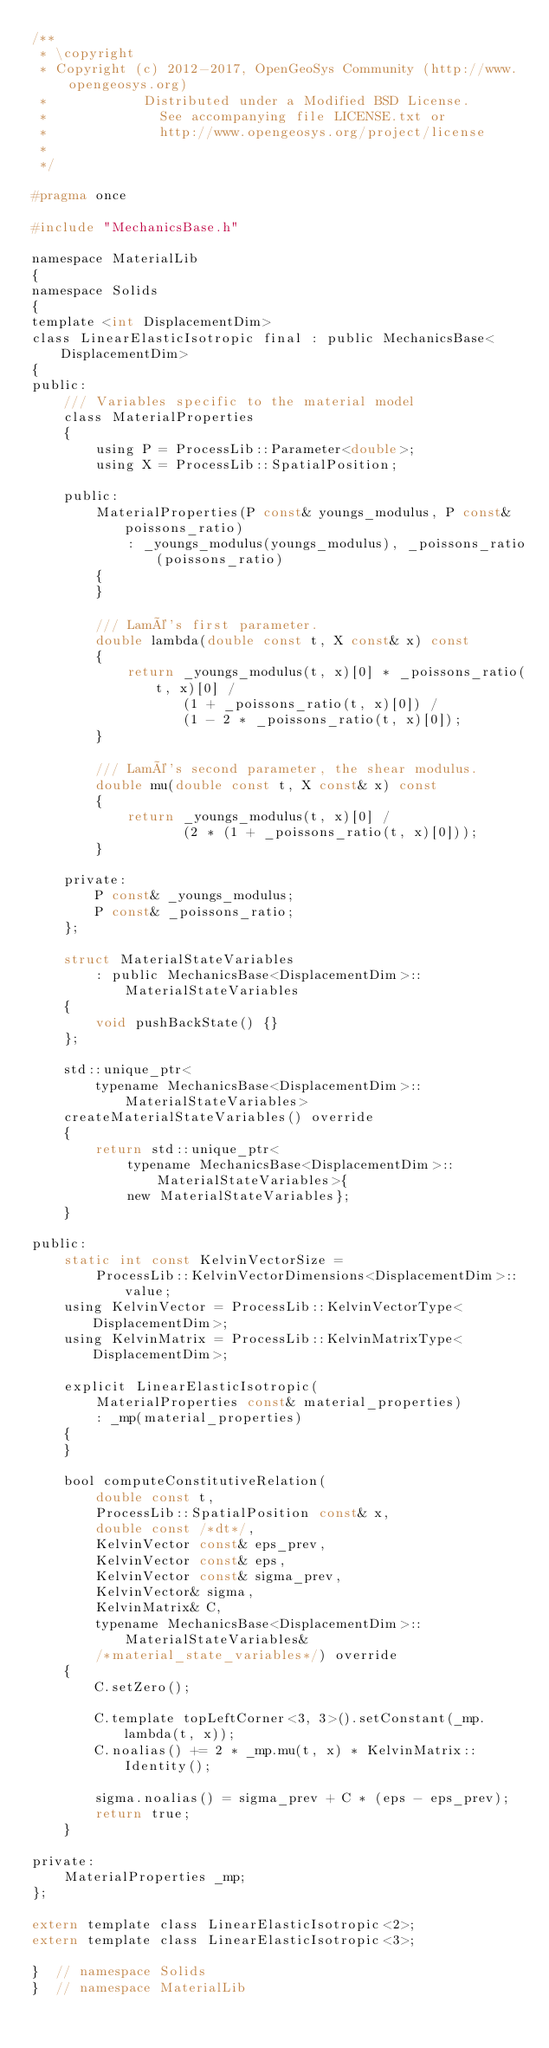<code> <loc_0><loc_0><loc_500><loc_500><_C_>/**
 * \copyright
 * Copyright (c) 2012-2017, OpenGeoSys Community (http://www.opengeosys.org)
 *            Distributed under a Modified BSD License.
 *              See accompanying file LICENSE.txt or
 *              http://www.opengeosys.org/project/license
 *
 */

#pragma once

#include "MechanicsBase.h"

namespace MaterialLib
{
namespace Solids
{
template <int DisplacementDim>
class LinearElasticIsotropic final : public MechanicsBase<DisplacementDim>
{
public:
    /// Variables specific to the material model
    class MaterialProperties
    {
        using P = ProcessLib::Parameter<double>;
        using X = ProcessLib::SpatialPosition;

    public:
        MaterialProperties(P const& youngs_modulus, P const& poissons_ratio)
            : _youngs_modulus(youngs_modulus), _poissons_ratio(poissons_ratio)
        {
        }

        /// Lamé's first parameter.
        double lambda(double const t, X const& x) const
        {
            return _youngs_modulus(t, x)[0] * _poissons_ratio(t, x)[0] /
                   (1 + _poissons_ratio(t, x)[0]) /
                   (1 - 2 * _poissons_ratio(t, x)[0]);
        }

        /// Lamé's second parameter, the shear modulus.
        double mu(double const t, X const& x) const
        {
            return _youngs_modulus(t, x)[0] /
                   (2 * (1 + _poissons_ratio(t, x)[0]));
        }

    private:
        P const& _youngs_modulus;
        P const& _poissons_ratio;
    };

    struct MaterialStateVariables
        : public MechanicsBase<DisplacementDim>::MaterialStateVariables
    {
        void pushBackState() {}
    };

    std::unique_ptr<
        typename MechanicsBase<DisplacementDim>::MaterialStateVariables>
    createMaterialStateVariables() override
    {
        return std::unique_ptr<
            typename MechanicsBase<DisplacementDim>::MaterialStateVariables>{
            new MaterialStateVariables};
    }

public:
    static int const KelvinVectorSize =
        ProcessLib::KelvinVectorDimensions<DisplacementDim>::value;
    using KelvinVector = ProcessLib::KelvinVectorType<DisplacementDim>;
    using KelvinMatrix = ProcessLib::KelvinMatrixType<DisplacementDim>;

    explicit LinearElasticIsotropic(
        MaterialProperties const& material_properties)
        : _mp(material_properties)
    {
    }

    bool computeConstitutiveRelation(
        double const t,
        ProcessLib::SpatialPosition const& x,
        double const /*dt*/,
        KelvinVector const& eps_prev,
        KelvinVector const& eps,
        KelvinVector const& sigma_prev,
        KelvinVector& sigma,
        KelvinMatrix& C,
        typename MechanicsBase<DisplacementDim>::MaterialStateVariables&
        /*material_state_variables*/) override
    {
        C.setZero();

        C.template topLeftCorner<3, 3>().setConstant(_mp.lambda(t, x));
        C.noalias() += 2 * _mp.mu(t, x) * KelvinMatrix::Identity();

        sigma.noalias() = sigma_prev + C * (eps - eps_prev);
        return true;
    }

private:
    MaterialProperties _mp;
};

extern template class LinearElasticIsotropic<2>;
extern template class LinearElasticIsotropic<3>;

}  // namespace Solids
}  // namespace MaterialLib
</code> 